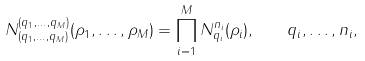Convert formula to latex. <formula><loc_0><loc_0><loc_500><loc_500>N _ { ( q _ { 1 } , \dots , q _ { M } ) } ^ { ( q _ { 1 } , \dots , q _ { M } ) } ( \rho _ { 1 } , \dots , \rho _ { M } ) = \prod _ { i = 1 } ^ { M } N _ { q _ { i } } ^ { n _ { i } } ( \rho _ { i } ) , \quad q _ { i } , \dots , n _ { i } ,</formula> 